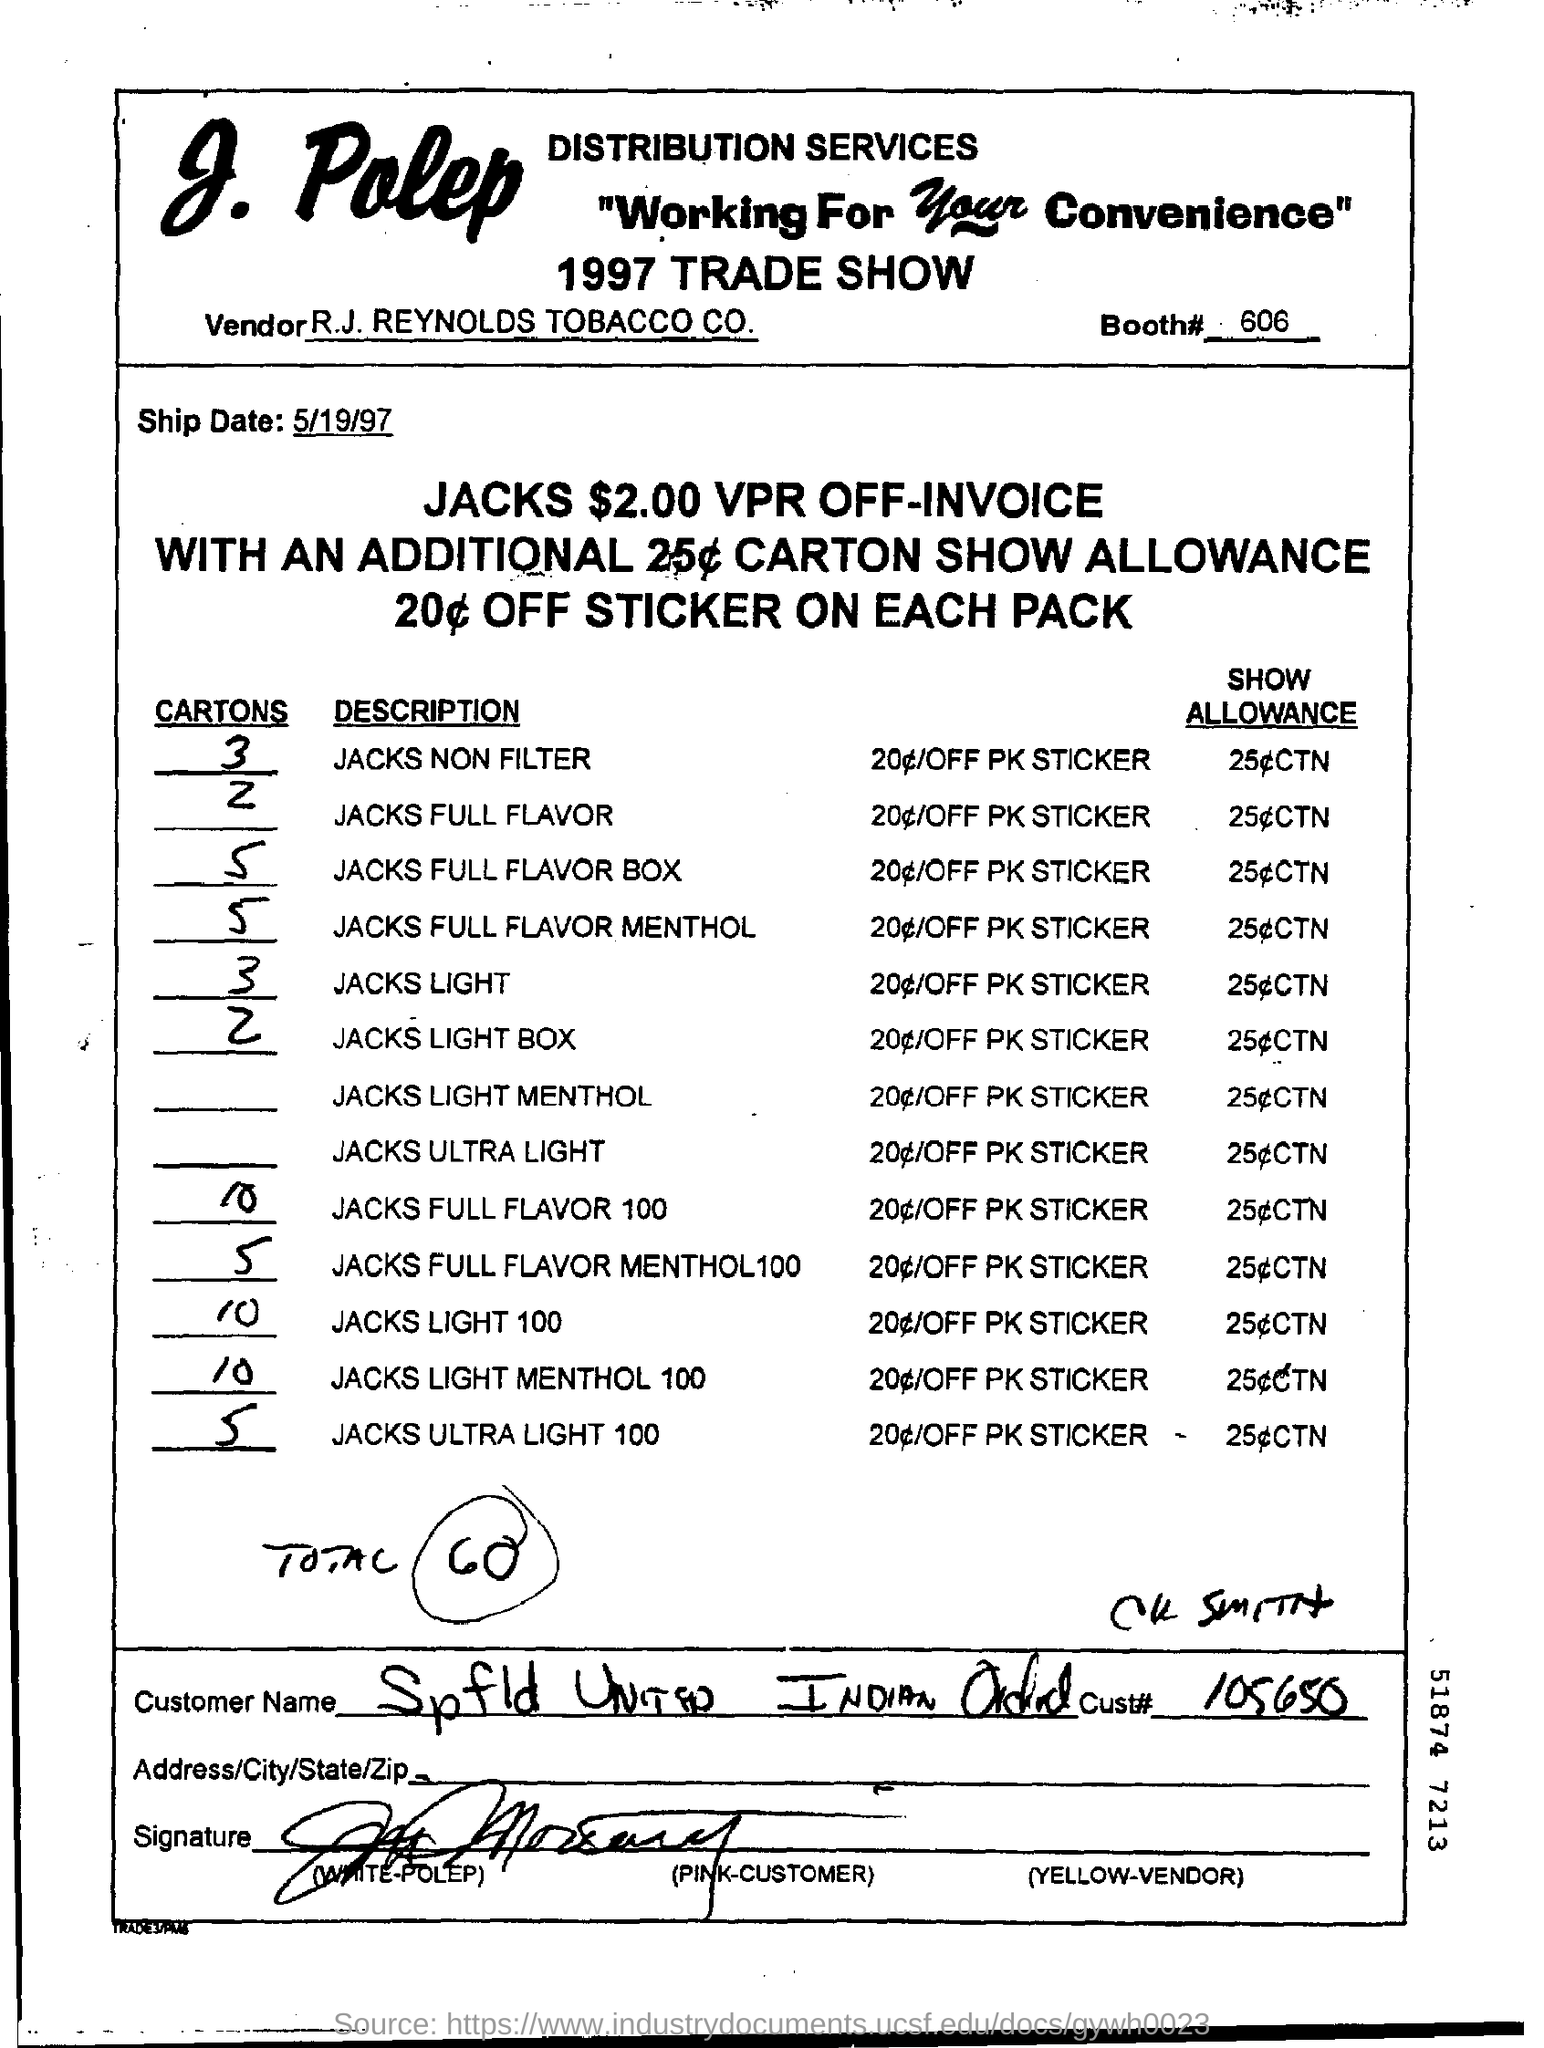List a handful of essential elements in this visual. What is the customer number? 105650..." is a question asking for information about a specific customer number. The vendor name is R.J. Reynolds Tobacco Company. The total number mentioned is 60. The booth number is 606. The ship date is May 19, 1997. 